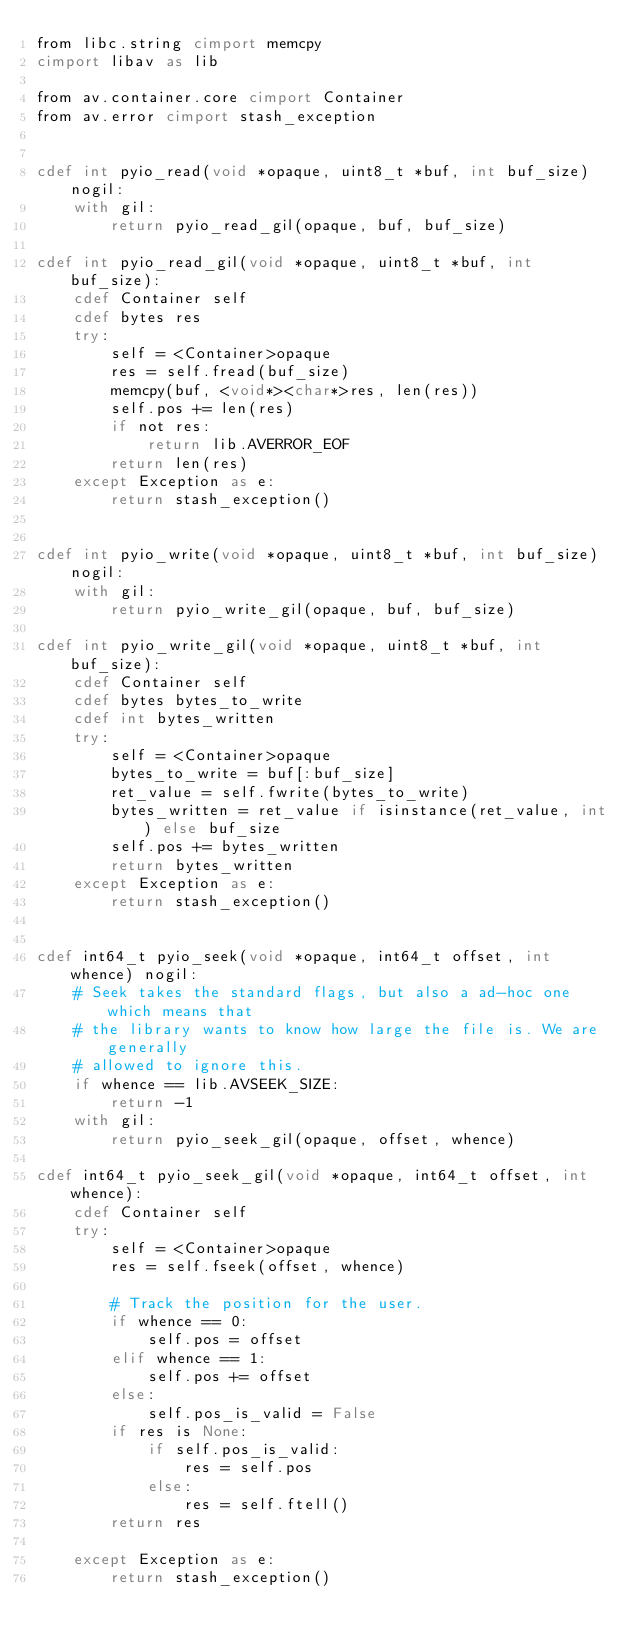Convert code to text. <code><loc_0><loc_0><loc_500><loc_500><_Cython_>from libc.string cimport memcpy
cimport libav as lib

from av.container.core cimport Container
from av.error cimport stash_exception


cdef int pyio_read(void *opaque, uint8_t *buf, int buf_size) nogil:
    with gil:
        return pyio_read_gil(opaque, buf, buf_size)

cdef int pyio_read_gil(void *opaque, uint8_t *buf, int buf_size):
    cdef Container self
    cdef bytes res
    try:
        self = <Container>opaque
        res = self.fread(buf_size)
        memcpy(buf, <void*><char*>res, len(res))
        self.pos += len(res)
        if not res:
            return lib.AVERROR_EOF
        return len(res)
    except Exception as e:
        return stash_exception()


cdef int pyio_write(void *opaque, uint8_t *buf, int buf_size) nogil:
    with gil:
        return pyio_write_gil(opaque, buf, buf_size)

cdef int pyio_write_gil(void *opaque, uint8_t *buf, int buf_size):
    cdef Container self
    cdef bytes bytes_to_write
    cdef int bytes_written
    try:
        self = <Container>opaque
        bytes_to_write = buf[:buf_size]
        ret_value = self.fwrite(bytes_to_write)
        bytes_written = ret_value if isinstance(ret_value, int) else buf_size
        self.pos += bytes_written
        return bytes_written
    except Exception as e:
        return stash_exception()


cdef int64_t pyio_seek(void *opaque, int64_t offset, int whence) nogil:
    # Seek takes the standard flags, but also a ad-hoc one which means that
    # the library wants to know how large the file is. We are generally
    # allowed to ignore this.
    if whence == lib.AVSEEK_SIZE:
        return -1
    with gil:
        return pyio_seek_gil(opaque, offset, whence)

cdef int64_t pyio_seek_gil(void *opaque, int64_t offset, int whence):
    cdef Container self
    try:
        self = <Container>opaque
        res = self.fseek(offset, whence)

        # Track the position for the user.
        if whence == 0:
            self.pos = offset
        elif whence == 1:
            self.pos += offset
        else:
            self.pos_is_valid = False
        if res is None:
            if self.pos_is_valid:
                res = self.pos
            else:
                res = self.ftell()
        return res

    except Exception as e:
        return stash_exception()
</code> 